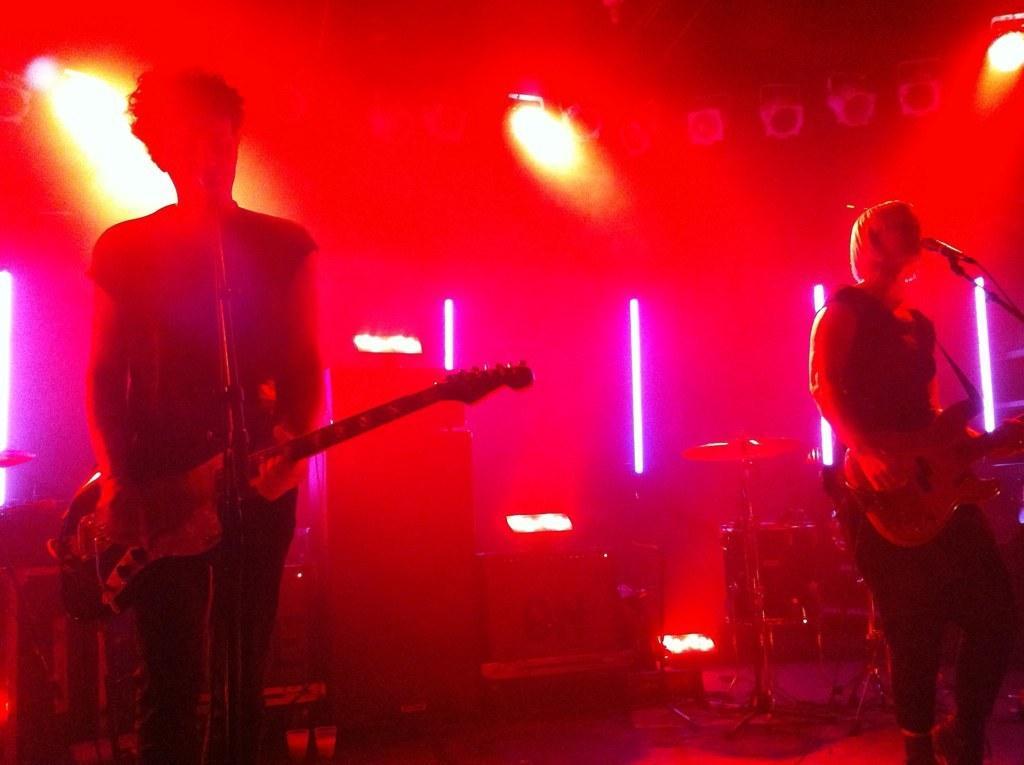Can you describe this image briefly? In this picture we can see two persons standing in front of mike and they are playing guitar. On the background we can see some lights. 